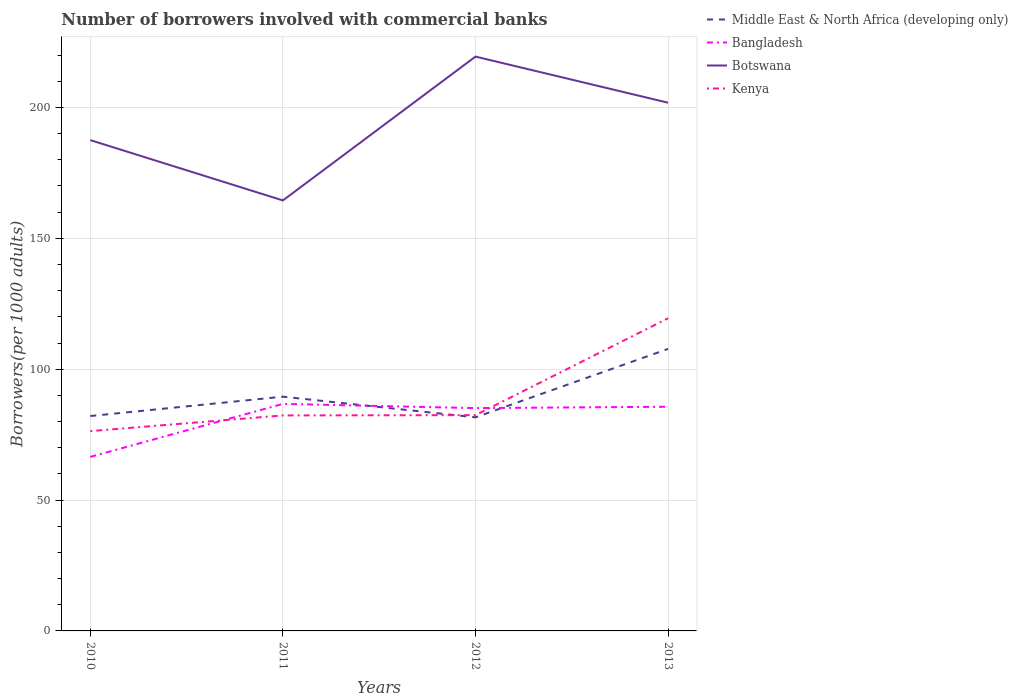How many different coloured lines are there?
Make the answer very short. 4. Is the number of lines equal to the number of legend labels?
Your answer should be very brief. Yes. Across all years, what is the maximum number of borrowers involved with commercial banks in Botswana?
Offer a very short reply. 164.48. In which year was the number of borrowers involved with commercial banks in Kenya maximum?
Offer a very short reply. 2010. What is the total number of borrowers involved with commercial banks in Kenya in the graph?
Keep it short and to the point. -37.12. What is the difference between the highest and the second highest number of borrowers involved with commercial banks in Botswana?
Make the answer very short. 54.96. Is the number of borrowers involved with commercial banks in Middle East & North Africa (developing only) strictly greater than the number of borrowers involved with commercial banks in Botswana over the years?
Keep it short and to the point. Yes. How many lines are there?
Your answer should be compact. 4. What is the difference between two consecutive major ticks on the Y-axis?
Offer a terse response. 50. What is the title of the graph?
Offer a very short reply. Number of borrowers involved with commercial banks. Does "Spain" appear as one of the legend labels in the graph?
Your answer should be very brief. No. What is the label or title of the Y-axis?
Ensure brevity in your answer.  Borrowers(per 1000 adults). What is the Borrowers(per 1000 adults) in Middle East & North Africa (developing only) in 2010?
Ensure brevity in your answer.  82.1. What is the Borrowers(per 1000 adults) of Bangladesh in 2010?
Provide a short and direct response. 66.49. What is the Borrowers(per 1000 adults) in Botswana in 2010?
Ensure brevity in your answer.  187.53. What is the Borrowers(per 1000 adults) in Kenya in 2010?
Your answer should be very brief. 76.34. What is the Borrowers(per 1000 adults) of Middle East & North Africa (developing only) in 2011?
Your answer should be very brief. 89.5. What is the Borrowers(per 1000 adults) in Bangladesh in 2011?
Make the answer very short. 86.74. What is the Borrowers(per 1000 adults) in Botswana in 2011?
Provide a short and direct response. 164.48. What is the Borrowers(per 1000 adults) in Kenya in 2011?
Your response must be concise. 82.34. What is the Borrowers(per 1000 adults) of Middle East & North Africa (developing only) in 2012?
Keep it short and to the point. 81.61. What is the Borrowers(per 1000 adults) of Bangladesh in 2012?
Ensure brevity in your answer.  85.13. What is the Borrowers(per 1000 adults) of Botswana in 2012?
Make the answer very short. 219.44. What is the Borrowers(per 1000 adults) of Kenya in 2012?
Provide a succinct answer. 82.45. What is the Borrowers(per 1000 adults) in Middle East & North Africa (developing only) in 2013?
Provide a succinct answer. 107.75. What is the Borrowers(per 1000 adults) in Bangladesh in 2013?
Offer a very short reply. 85.65. What is the Borrowers(per 1000 adults) in Botswana in 2013?
Provide a succinct answer. 201.82. What is the Borrowers(per 1000 adults) of Kenya in 2013?
Give a very brief answer. 119.46. Across all years, what is the maximum Borrowers(per 1000 adults) in Middle East & North Africa (developing only)?
Keep it short and to the point. 107.75. Across all years, what is the maximum Borrowers(per 1000 adults) of Bangladesh?
Offer a terse response. 86.74. Across all years, what is the maximum Borrowers(per 1000 adults) of Botswana?
Your answer should be very brief. 219.44. Across all years, what is the maximum Borrowers(per 1000 adults) in Kenya?
Ensure brevity in your answer.  119.46. Across all years, what is the minimum Borrowers(per 1000 adults) in Middle East & North Africa (developing only)?
Provide a succinct answer. 81.61. Across all years, what is the minimum Borrowers(per 1000 adults) of Bangladesh?
Offer a terse response. 66.49. Across all years, what is the minimum Borrowers(per 1000 adults) of Botswana?
Offer a very short reply. 164.48. Across all years, what is the minimum Borrowers(per 1000 adults) of Kenya?
Keep it short and to the point. 76.34. What is the total Borrowers(per 1000 adults) of Middle East & North Africa (developing only) in the graph?
Ensure brevity in your answer.  360.96. What is the total Borrowers(per 1000 adults) in Bangladesh in the graph?
Offer a very short reply. 324.02. What is the total Borrowers(per 1000 adults) in Botswana in the graph?
Make the answer very short. 773.26. What is the total Borrowers(per 1000 adults) in Kenya in the graph?
Keep it short and to the point. 360.58. What is the difference between the Borrowers(per 1000 adults) in Middle East & North Africa (developing only) in 2010 and that in 2011?
Offer a very short reply. -7.4. What is the difference between the Borrowers(per 1000 adults) of Bangladesh in 2010 and that in 2011?
Provide a short and direct response. -20.25. What is the difference between the Borrowers(per 1000 adults) of Botswana in 2010 and that in 2011?
Offer a terse response. 23.05. What is the difference between the Borrowers(per 1000 adults) in Kenya in 2010 and that in 2011?
Give a very brief answer. -6. What is the difference between the Borrowers(per 1000 adults) of Middle East & North Africa (developing only) in 2010 and that in 2012?
Ensure brevity in your answer.  0.5. What is the difference between the Borrowers(per 1000 adults) in Bangladesh in 2010 and that in 2012?
Make the answer very short. -18.64. What is the difference between the Borrowers(per 1000 adults) of Botswana in 2010 and that in 2012?
Your answer should be compact. -31.91. What is the difference between the Borrowers(per 1000 adults) in Kenya in 2010 and that in 2012?
Your answer should be compact. -6.11. What is the difference between the Borrowers(per 1000 adults) in Middle East & North Africa (developing only) in 2010 and that in 2013?
Your answer should be compact. -25.65. What is the difference between the Borrowers(per 1000 adults) in Bangladesh in 2010 and that in 2013?
Your response must be concise. -19.16. What is the difference between the Borrowers(per 1000 adults) of Botswana in 2010 and that in 2013?
Ensure brevity in your answer.  -14.29. What is the difference between the Borrowers(per 1000 adults) of Kenya in 2010 and that in 2013?
Your answer should be compact. -43.12. What is the difference between the Borrowers(per 1000 adults) in Middle East & North Africa (developing only) in 2011 and that in 2012?
Your answer should be very brief. 7.9. What is the difference between the Borrowers(per 1000 adults) in Bangladesh in 2011 and that in 2012?
Your answer should be very brief. 1.61. What is the difference between the Borrowers(per 1000 adults) in Botswana in 2011 and that in 2012?
Offer a terse response. -54.96. What is the difference between the Borrowers(per 1000 adults) in Kenya in 2011 and that in 2012?
Offer a very short reply. -0.11. What is the difference between the Borrowers(per 1000 adults) in Middle East & North Africa (developing only) in 2011 and that in 2013?
Your response must be concise. -18.25. What is the difference between the Borrowers(per 1000 adults) of Bangladesh in 2011 and that in 2013?
Offer a terse response. 1.09. What is the difference between the Borrowers(per 1000 adults) of Botswana in 2011 and that in 2013?
Offer a terse response. -37.34. What is the difference between the Borrowers(per 1000 adults) of Kenya in 2011 and that in 2013?
Offer a very short reply. -37.12. What is the difference between the Borrowers(per 1000 adults) of Middle East & North Africa (developing only) in 2012 and that in 2013?
Keep it short and to the point. -26.15. What is the difference between the Borrowers(per 1000 adults) of Bangladesh in 2012 and that in 2013?
Give a very brief answer. -0.52. What is the difference between the Borrowers(per 1000 adults) of Botswana in 2012 and that in 2013?
Give a very brief answer. 17.62. What is the difference between the Borrowers(per 1000 adults) of Kenya in 2012 and that in 2013?
Offer a terse response. -37.01. What is the difference between the Borrowers(per 1000 adults) in Middle East & North Africa (developing only) in 2010 and the Borrowers(per 1000 adults) in Bangladesh in 2011?
Your response must be concise. -4.64. What is the difference between the Borrowers(per 1000 adults) in Middle East & North Africa (developing only) in 2010 and the Borrowers(per 1000 adults) in Botswana in 2011?
Give a very brief answer. -82.38. What is the difference between the Borrowers(per 1000 adults) of Middle East & North Africa (developing only) in 2010 and the Borrowers(per 1000 adults) of Kenya in 2011?
Your response must be concise. -0.24. What is the difference between the Borrowers(per 1000 adults) of Bangladesh in 2010 and the Borrowers(per 1000 adults) of Botswana in 2011?
Provide a succinct answer. -97.98. What is the difference between the Borrowers(per 1000 adults) of Bangladesh in 2010 and the Borrowers(per 1000 adults) of Kenya in 2011?
Give a very brief answer. -15.84. What is the difference between the Borrowers(per 1000 adults) in Botswana in 2010 and the Borrowers(per 1000 adults) in Kenya in 2011?
Provide a short and direct response. 105.19. What is the difference between the Borrowers(per 1000 adults) in Middle East & North Africa (developing only) in 2010 and the Borrowers(per 1000 adults) in Bangladesh in 2012?
Make the answer very short. -3.03. What is the difference between the Borrowers(per 1000 adults) of Middle East & North Africa (developing only) in 2010 and the Borrowers(per 1000 adults) of Botswana in 2012?
Keep it short and to the point. -137.34. What is the difference between the Borrowers(per 1000 adults) of Middle East & North Africa (developing only) in 2010 and the Borrowers(per 1000 adults) of Kenya in 2012?
Provide a short and direct response. -0.35. What is the difference between the Borrowers(per 1000 adults) of Bangladesh in 2010 and the Borrowers(per 1000 adults) of Botswana in 2012?
Provide a short and direct response. -152.94. What is the difference between the Borrowers(per 1000 adults) of Bangladesh in 2010 and the Borrowers(per 1000 adults) of Kenya in 2012?
Keep it short and to the point. -15.95. What is the difference between the Borrowers(per 1000 adults) of Botswana in 2010 and the Borrowers(per 1000 adults) of Kenya in 2012?
Provide a succinct answer. 105.08. What is the difference between the Borrowers(per 1000 adults) in Middle East & North Africa (developing only) in 2010 and the Borrowers(per 1000 adults) in Bangladesh in 2013?
Keep it short and to the point. -3.55. What is the difference between the Borrowers(per 1000 adults) of Middle East & North Africa (developing only) in 2010 and the Borrowers(per 1000 adults) of Botswana in 2013?
Ensure brevity in your answer.  -119.72. What is the difference between the Borrowers(per 1000 adults) of Middle East & North Africa (developing only) in 2010 and the Borrowers(per 1000 adults) of Kenya in 2013?
Make the answer very short. -37.36. What is the difference between the Borrowers(per 1000 adults) of Bangladesh in 2010 and the Borrowers(per 1000 adults) of Botswana in 2013?
Give a very brief answer. -135.32. What is the difference between the Borrowers(per 1000 adults) in Bangladesh in 2010 and the Borrowers(per 1000 adults) in Kenya in 2013?
Your answer should be very brief. -52.97. What is the difference between the Borrowers(per 1000 adults) in Botswana in 2010 and the Borrowers(per 1000 adults) in Kenya in 2013?
Your response must be concise. 68.07. What is the difference between the Borrowers(per 1000 adults) in Middle East & North Africa (developing only) in 2011 and the Borrowers(per 1000 adults) in Bangladesh in 2012?
Provide a short and direct response. 4.37. What is the difference between the Borrowers(per 1000 adults) in Middle East & North Africa (developing only) in 2011 and the Borrowers(per 1000 adults) in Botswana in 2012?
Your answer should be compact. -129.94. What is the difference between the Borrowers(per 1000 adults) of Middle East & North Africa (developing only) in 2011 and the Borrowers(per 1000 adults) of Kenya in 2012?
Offer a very short reply. 7.05. What is the difference between the Borrowers(per 1000 adults) in Bangladesh in 2011 and the Borrowers(per 1000 adults) in Botswana in 2012?
Offer a very short reply. -132.7. What is the difference between the Borrowers(per 1000 adults) of Bangladesh in 2011 and the Borrowers(per 1000 adults) of Kenya in 2012?
Your answer should be compact. 4.3. What is the difference between the Borrowers(per 1000 adults) of Botswana in 2011 and the Borrowers(per 1000 adults) of Kenya in 2012?
Provide a succinct answer. 82.03. What is the difference between the Borrowers(per 1000 adults) in Middle East & North Africa (developing only) in 2011 and the Borrowers(per 1000 adults) in Bangladesh in 2013?
Your answer should be compact. 3.85. What is the difference between the Borrowers(per 1000 adults) of Middle East & North Africa (developing only) in 2011 and the Borrowers(per 1000 adults) of Botswana in 2013?
Keep it short and to the point. -112.32. What is the difference between the Borrowers(per 1000 adults) in Middle East & North Africa (developing only) in 2011 and the Borrowers(per 1000 adults) in Kenya in 2013?
Keep it short and to the point. -29.96. What is the difference between the Borrowers(per 1000 adults) of Bangladesh in 2011 and the Borrowers(per 1000 adults) of Botswana in 2013?
Make the answer very short. -115.07. What is the difference between the Borrowers(per 1000 adults) of Bangladesh in 2011 and the Borrowers(per 1000 adults) of Kenya in 2013?
Provide a succinct answer. -32.72. What is the difference between the Borrowers(per 1000 adults) in Botswana in 2011 and the Borrowers(per 1000 adults) in Kenya in 2013?
Provide a succinct answer. 45.02. What is the difference between the Borrowers(per 1000 adults) in Middle East & North Africa (developing only) in 2012 and the Borrowers(per 1000 adults) in Bangladesh in 2013?
Provide a short and direct response. -4.05. What is the difference between the Borrowers(per 1000 adults) in Middle East & North Africa (developing only) in 2012 and the Borrowers(per 1000 adults) in Botswana in 2013?
Ensure brevity in your answer.  -120.21. What is the difference between the Borrowers(per 1000 adults) in Middle East & North Africa (developing only) in 2012 and the Borrowers(per 1000 adults) in Kenya in 2013?
Provide a succinct answer. -37.85. What is the difference between the Borrowers(per 1000 adults) in Bangladesh in 2012 and the Borrowers(per 1000 adults) in Botswana in 2013?
Provide a short and direct response. -116.68. What is the difference between the Borrowers(per 1000 adults) in Bangladesh in 2012 and the Borrowers(per 1000 adults) in Kenya in 2013?
Make the answer very short. -34.33. What is the difference between the Borrowers(per 1000 adults) of Botswana in 2012 and the Borrowers(per 1000 adults) of Kenya in 2013?
Offer a very short reply. 99.98. What is the average Borrowers(per 1000 adults) in Middle East & North Africa (developing only) per year?
Ensure brevity in your answer.  90.24. What is the average Borrowers(per 1000 adults) in Bangladesh per year?
Make the answer very short. 81.01. What is the average Borrowers(per 1000 adults) in Botswana per year?
Ensure brevity in your answer.  193.32. What is the average Borrowers(per 1000 adults) of Kenya per year?
Keep it short and to the point. 90.15. In the year 2010, what is the difference between the Borrowers(per 1000 adults) of Middle East & North Africa (developing only) and Borrowers(per 1000 adults) of Bangladesh?
Provide a short and direct response. 15.61. In the year 2010, what is the difference between the Borrowers(per 1000 adults) of Middle East & North Africa (developing only) and Borrowers(per 1000 adults) of Botswana?
Your response must be concise. -105.43. In the year 2010, what is the difference between the Borrowers(per 1000 adults) in Middle East & North Africa (developing only) and Borrowers(per 1000 adults) in Kenya?
Keep it short and to the point. 5.76. In the year 2010, what is the difference between the Borrowers(per 1000 adults) of Bangladesh and Borrowers(per 1000 adults) of Botswana?
Offer a very short reply. -121.03. In the year 2010, what is the difference between the Borrowers(per 1000 adults) of Bangladesh and Borrowers(per 1000 adults) of Kenya?
Offer a terse response. -9.85. In the year 2010, what is the difference between the Borrowers(per 1000 adults) in Botswana and Borrowers(per 1000 adults) in Kenya?
Make the answer very short. 111.19. In the year 2011, what is the difference between the Borrowers(per 1000 adults) of Middle East & North Africa (developing only) and Borrowers(per 1000 adults) of Bangladesh?
Keep it short and to the point. 2.76. In the year 2011, what is the difference between the Borrowers(per 1000 adults) in Middle East & North Africa (developing only) and Borrowers(per 1000 adults) in Botswana?
Offer a very short reply. -74.98. In the year 2011, what is the difference between the Borrowers(per 1000 adults) of Middle East & North Africa (developing only) and Borrowers(per 1000 adults) of Kenya?
Your answer should be very brief. 7.16. In the year 2011, what is the difference between the Borrowers(per 1000 adults) of Bangladesh and Borrowers(per 1000 adults) of Botswana?
Provide a short and direct response. -77.74. In the year 2011, what is the difference between the Borrowers(per 1000 adults) in Bangladesh and Borrowers(per 1000 adults) in Kenya?
Provide a succinct answer. 4.41. In the year 2011, what is the difference between the Borrowers(per 1000 adults) of Botswana and Borrowers(per 1000 adults) of Kenya?
Your answer should be very brief. 82.14. In the year 2012, what is the difference between the Borrowers(per 1000 adults) in Middle East & North Africa (developing only) and Borrowers(per 1000 adults) in Bangladesh?
Provide a short and direct response. -3.53. In the year 2012, what is the difference between the Borrowers(per 1000 adults) of Middle East & North Africa (developing only) and Borrowers(per 1000 adults) of Botswana?
Offer a terse response. -137.83. In the year 2012, what is the difference between the Borrowers(per 1000 adults) of Middle East & North Africa (developing only) and Borrowers(per 1000 adults) of Kenya?
Offer a terse response. -0.84. In the year 2012, what is the difference between the Borrowers(per 1000 adults) of Bangladesh and Borrowers(per 1000 adults) of Botswana?
Provide a succinct answer. -134.3. In the year 2012, what is the difference between the Borrowers(per 1000 adults) in Bangladesh and Borrowers(per 1000 adults) in Kenya?
Offer a terse response. 2.69. In the year 2012, what is the difference between the Borrowers(per 1000 adults) in Botswana and Borrowers(per 1000 adults) in Kenya?
Offer a terse response. 136.99. In the year 2013, what is the difference between the Borrowers(per 1000 adults) in Middle East & North Africa (developing only) and Borrowers(per 1000 adults) in Bangladesh?
Ensure brevity in your answer.  22.1. In the year 2013, what is the difference between the Borrowers(per 1000 adults) of Middle East & North Africa (developing only) and Borrowers(per 1000 adults) of Botswana?
Make the answer very short. -94.06. In the year 2013, what is the difference between the Borrowers(per 1000 adults) in Middle East & North Africa (developing only) and Borrowers(per 1000 adults) in Kenya?
Give a very brief answer. -11.71. In the year 2013, what is the difference between the Borrowers(per 1000 adults) in Bangladesh and Borrowers(per 1000 adults) in Botswana?
Offer a terse response. -116.16. In the year 2013, what is the difference between the Borrowers(per 1000 adults) of Bangladesh and Borrowers(per 1000 adults) of Kenya?
Give a very brief answer. -33.81. In the year 2013, what is the difference between the Borrowers(per 1000 adults) of Botswana and Borrowers(per 1000 adults) of Kenya?
Give a very brief answer. 82.36. What is the ratio of the Borrowers(per 1000 adults) in Middle East & North Africa (developing only) in 2010 to that in 2011?
Your answer should be very brief. 0.92. What is the ratio of the Borrowers(per 1000 adults) in Bangladesh in 2010 to that in 2011?
Make the answer very short. 0.77. What is the ratio of the Borrowers(per 1000 adults) in Botswana in 2010 to that in 2011?
Provide a succinct answer. 1.14. What is the ratio of the Borrowers(per 1000 adults) of Kenya in 2010 to that in 2011?
Make the answer very short. 0.93. What is the ratio of the Borrowers(per 1000 adults) in Bangladesh in 2010 to that in 2012?
Your answer should be very brief. 0.78. What is the ratio of the Borrowers(per 1000 adults) in Botswana in 2010 to that in 2012?
Provide a succinct answer. 0.85. What is the ratio of the Borrowers(per 1000 adults) in Kenya in 2010 to that in 2012?
Give a very brief answer. 0.93. What is the ratio of the Borrowers(per 1000 adults) in Middle East & North Africa (developing only) in 2010 to that in 2013?
Make the answer very short. 0.76. What is the ratio of the Borrowers(per 1000 adults) of Bangladesh in 2010 to that in 2013?
Give a very brief answer. 0.78. What is the ratio of the Borrowers(per 1000 adults) in Botswana in 2010 to that in 2013?
Your response must be concise. 0.93. What is the ratio of the Borrowers(per 1000 adults) of Kenya in 2010 to that in 2013?
Make the answer very short. 0.64. What is the ratio of the Borrowers(per 1000 adults) of Middle East & North Africa (developing only) in 2011 to that in 2012?
Offer a terse response. 1.1. What is the ratio of the Borrowers(per 1000 adults) in Bangladesh in 2011 to that in 2012?
Offer a very short reply. 1.02. What is the ratio of the Borrowers(per 1000 adults) in Botswana in 2011 to that in 2012?
Offer a terse response. 0.75. What is the ratio of the Borrowers(per 1000 adults) of Kenya in 2011 to that in 2012?
Your answer should be very brief. 1. What is the ratio of the Borrowers(per 1000 adults) of Middle East & North Africa (developing only) in 2011 to that in 2013?
Provide a short and direct response. 0.83. What is the ratio of the Borrowers(per 1000 adults) in Bangladesh in 2011 to that in 2013?
Your response must be concise. 1.01. What is the ratio of the Borrowers(per 1000 adults) of Botswana in 2011 to that in 2013?
Make the answer very short. 0.81. What is the ratio of the Borrowers(per 1000 adults) in Kenya in 2011 to that in 2013?
Your answer should be compact. 0.69. What is the ratio of the Borrowers(per 1000 adults) of Middle East & North Africa (developing only) in 2012 to that in 2013?
Your answer should be very brief. 0.76. What is the ratio of the Borrowers(per 1000 adults) of Bangladesh in 2012 to that in 2013?
Your answer should be compact. 0.99. What is the ratio of the Borrowers(per 1000 adults) of Botswana in 2012 to that in 2013?
Provide a short and direct response. 1.09. What is the ratio of the Borrowers(per 1000 adults) in Kenya in 2012 to that in 2013?
Give a very brief answer. 0.69. What is the difference between the highest and the second highest Borrowers(per 1000 adults) in Middle East & North Africa (developing only)?
Your answer should be compact. 18.25. What is the difference between the highest and the second highest Borrowers(per 1000 adults) in Bangladesh?
Your response must be concise. 1.09. What is the difference between the highest and the second highest Borrowers(per 1000 adults) of Botswana?
Give a very brief answer. 17.62. What is the difference between the highest and the second highest Borrowers(per 1000 adults) in Kenya?
Ensure brevity in your answer.  37.01. What is the difference between the highest and the lowest Borrowers(per 1000 adults) of Middle East & North Africa (developing only)?
Offer a terse response. 26.15. What is the difference between the highest and the lowest Borrowers(per 1000 adults) of Bangladesh?
Keep it short and to the point. 20.25. What is the difference between the highest and the lowest Borrowers(per 1000 adults) in Botswana?
Your response must be concise. 54.96. What is the difference between the highest and the lowest Borrowers(per 1000 adults) in Kenya?
Give a very brief answer. 43.12. 